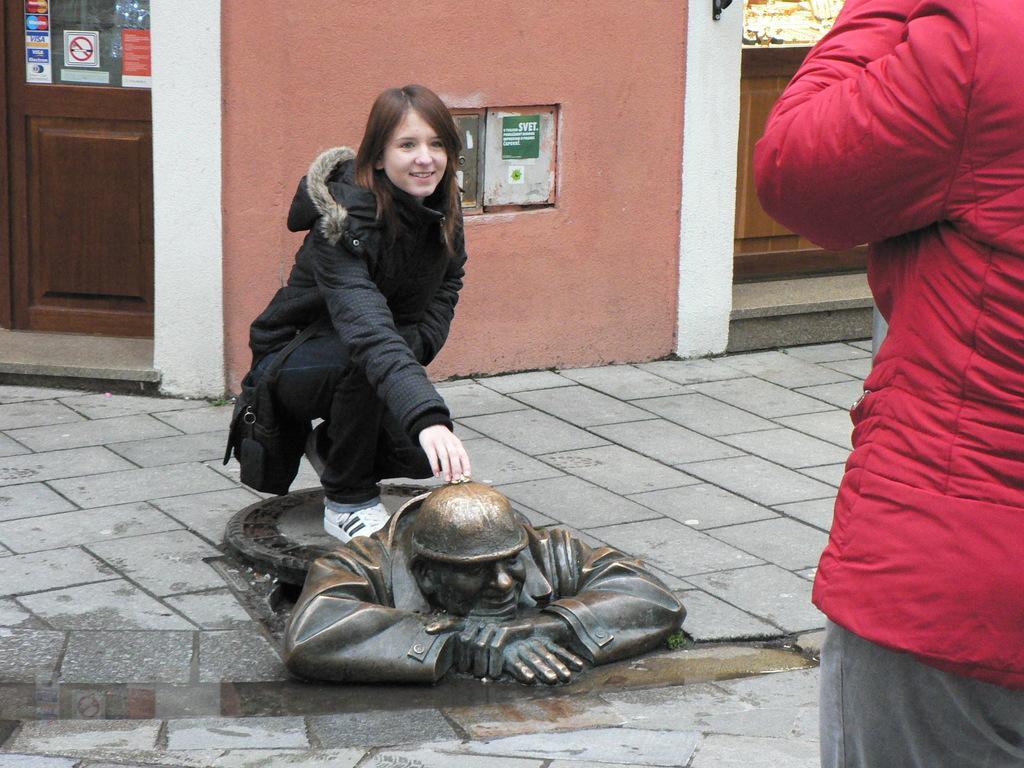Could you give a brief overview of what you see in this image? In this image we can see a girl. At the bottom of the image, we can see a sculpture on the pavement. In the background, we can see a wall and a door. There is one more person on the right side of the image. 